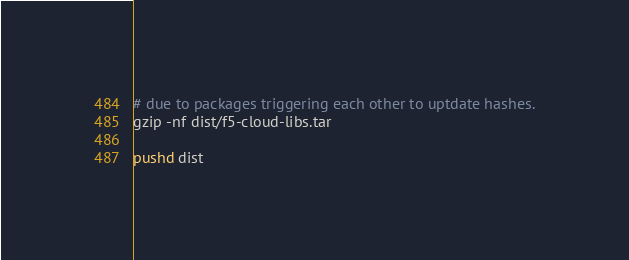<code> <loc_0><loc_0><loc_500><loc_500><_Bash_># due to packages triggering each other to uptdate hashes.
gzip -nf dist/f5-cloud-libs.tar

pushd dist</code> 